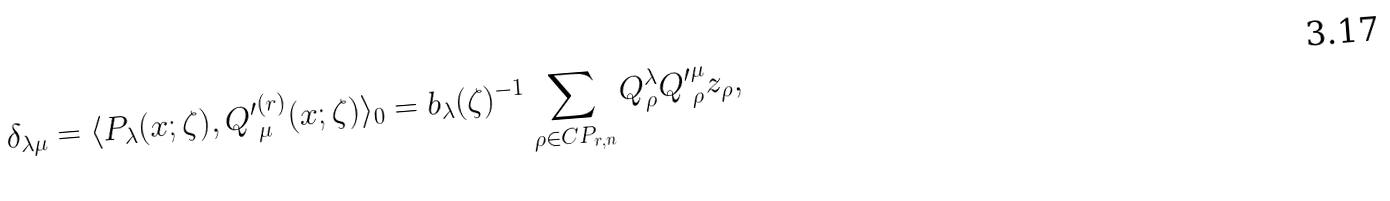Convert formula to latex. <formula><loc_0><loc_0><loc_500><loc_500>\delta _ { \lambda \mu } = \langle P _ { \lambda } ( x ; \zeta ) , { Q ^ { \prime } } ^ { ( r ) } _ { \mu } ( x ; \zeta ) \rangle _ { 0 } = b _ { \lambda } ( \zeta ) ^ { - 1 } \sum _ { \rho \in C P _ { r , n } } Q _ { \rho } ^ { \lambda } { Q ^ { \prime } } _ { \rho } ^ { \mu } z _ { \rho } ,</formula> 